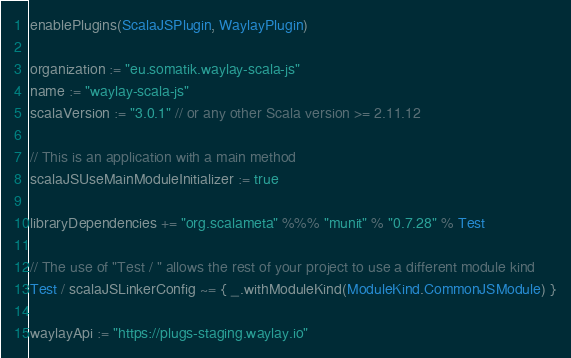Convert code to text. <code><loc_0><loc_0><loc_500><loc_500><_Scala_>enablePlugins(ScalaJSPlugin, WaylayPlugin)

organization := "eu.somatik.waylay-scala-js"
name := "waylay-scala-js"
scalaVersion := "3.0.1" // or any other Scala version >= 2.11.12

// This is an application with a main method
scalaJSUseMainModuleInitializer := true

libraryDependencies += "org.scalameta" %%% "munit" % "0.7.28" % Test

// The use of "Test / " allows the rest of your project to use a different module kind
Test / scalaJSLinkerConfig ~= { _.withModuleKind(ModuleKind.CommonJSModule) }

waylayApi := "https://plugs-staging.waylay.io"
</code> 